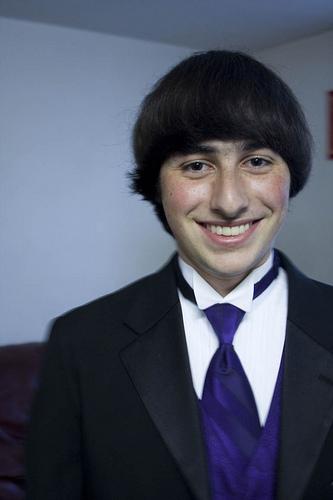Where is the man looking at?
Concise answer only. Camera. What color is the tie?
Be succinct. Blue. What is the man doing?
Quick response, please. Smiling. What is the boy's hair color?
Keep it brief. Black. Which of the man's facial features are missing from this picture?
Keep it brief. Ears. What expression is on the man's face?
Keep it brief. Smile. Is the man wearing glasses?
Quick response, please. No. Is this a businessman?
Answer briefly. No. Has this picture been taken in the last year?
Concise answer only. Yes. What color is the man's eyes?
Keep it brief. Brown. How many front teeth is this man showing?
Short answer required. 6. Is the man smiling at the camera?
Give a very brief answer. Yes. Does the man have curly hair?
Give a very brief answer. No. Is the man wearing a red necktie?
Be succinct. No. What design does the man's tie have?
Give a very brief answer. Stripes. What color is the kid's tie in the picture?
Short answer required. Blue. Does he need to shave?
Write a very short answer. No. Is the man balding?
Answer briefly. No. Is this man sad?
Give a very brief answer. No. What color eyes does this person have?
Give a very brief answer. Brown. Is this person wearing glasses?
Be succinct. No. What would this haircut be called?
Short answer required. Bowl cut. What color is the man's shirt?
Keep it brief. White. What is different about the man's suit that shows this is for a special occasion?
Concise answer only. Tie. What kind of business do you think this guy runs?
Answer briefly. None. 